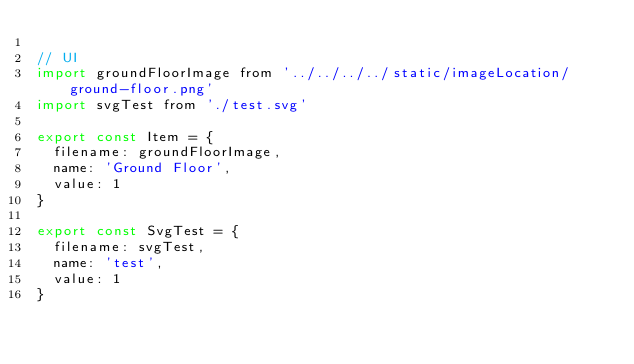<code> <loc_0><loc_0><loc_500><loc_500><_JavaScript_>
// UI
import groundFloorImage from '../../../../static/imageLocation/ground-floor.png'
import svgTest from './test.svg'

export const Item = {
  filename: groundFloorImage,
  name: 'Ground Floor',
  value: 1
}

export const SvgTest = {
  filename: svgTest,
  name: 'test',
  value: 1
}
</code> 